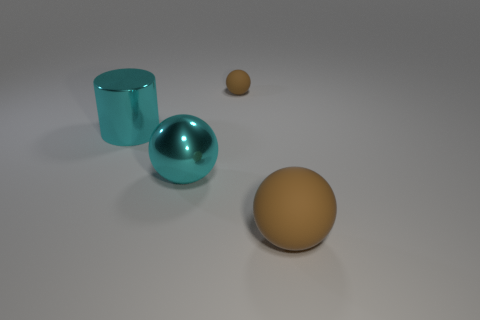How many brown balls are the same size as the cylinder?
Provide a short and direct response. 1. There is a ball that is in front of the tiny sphere and left of the big brown object; what is its color?
Give a very brief answer. Cyan. Is the number of tiny gray shiny cylinders less than the number of big brown things?
Give a very brief answer. Yes. Do the large metal sphere and the ball right of the tiny brown object have the same color?
Give a very brief answer. No. Are there the same number of large brown rubber balls that are behind the tiny brown object and cyan spheres that are behind the big cyan sphere?
Offer a very short reply. Yes. How many other large matte objects have the same shape as the large matte object?
Your answer should be compact. 0. Are there any small brown shiny things?
Give a very brief answer. No. Is the large brown sphere made of the same material as the large ball to the left of the large brown matte thing?
Your answer should be compact. No. What is the material of the brown thing that is the same size as the cyan cylinder?
Keep it short and to the point. Rubber. Is there a big gray block that has the same material as the cyan cylinder?
Provide a succinct answer. No. 